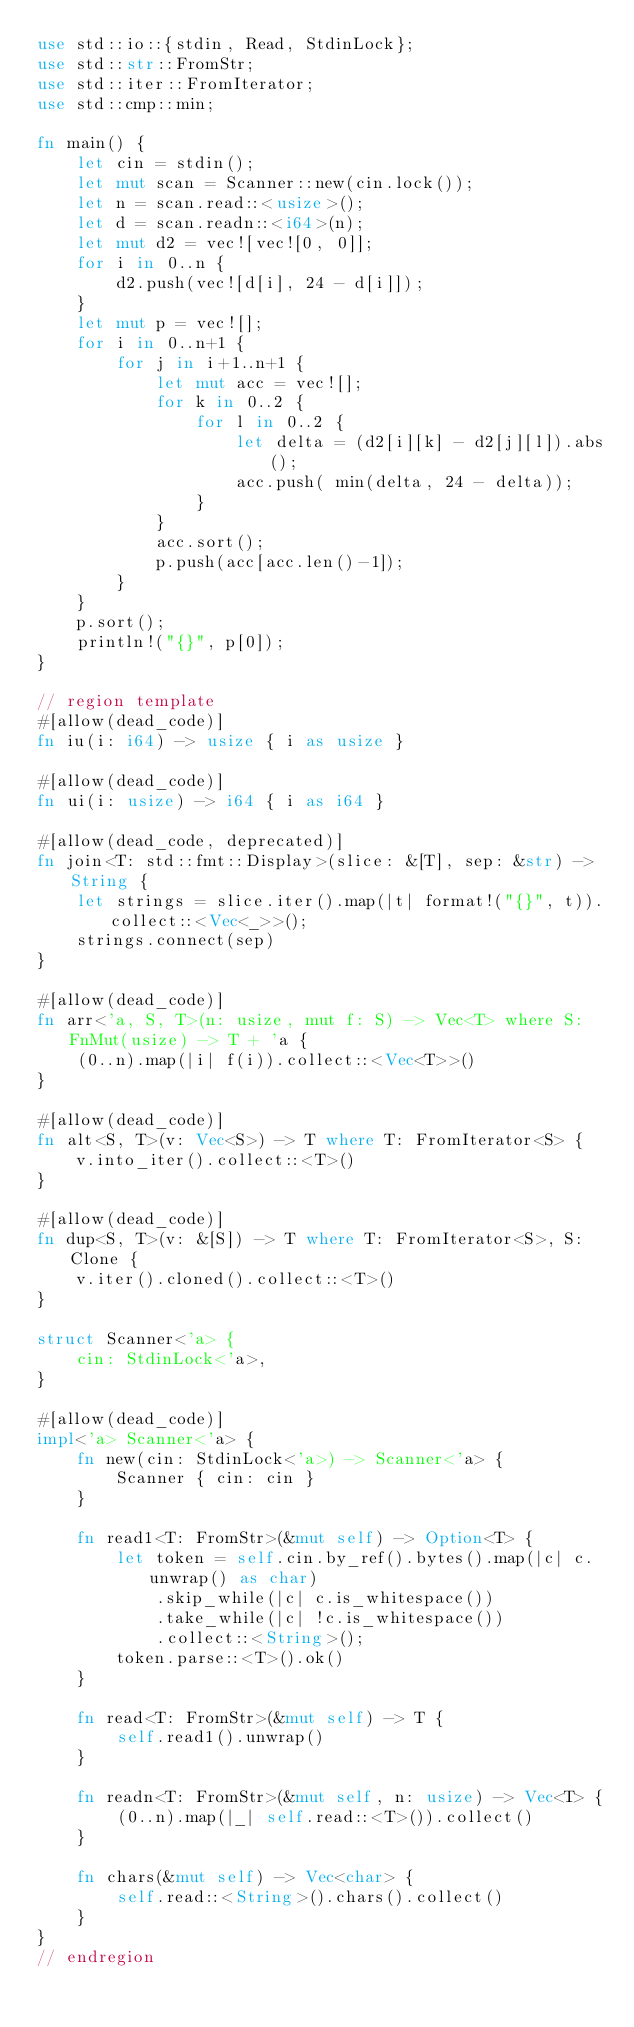Convert code to text. <code><loc_0><loc_0><loc_500><loc_500><_Rust_>use std::io::{stdin, Read, StdinLock};
use std::str::FromStr;
use std::iter::FromIterator;
use std::cmp::min;

fn main() {
    let cin = stdin();
    let mut scan = Scanner::new(cin.lock());
    let n = scan.read::<usize>();
    let d = scan.readn::<i64>(n);
    let mut d2 = vec![vec![0, 0]];
    for i in 0..n {
        d2.push(vec![d[i], 24 - d[i]]);
    }
    let mut p = vec![];
    for i in 0..n+1 {
        for j in i+1..n+1 {
            let mut acc = vec![];
            for k in 0..2 {
                for l in 0..2 {
                    let delta = (d2[i][k] - d2[j][l]).abs();
                    acc.push( min(delta, 24 - delta));
                }
            }
            acc.sort();
            p.push(acc[acc.len()-1]);
        }
    }
    p.sort();
    println!("{}", p[0]);
}

// region template
#[allow(dead_code)]
fn iu(i: i64) -> usize { i as usize }

#[allow(dead_code)]
fn ui(i: usize) -> i64 { i as i64 }

#[allow(dead_code, deprecated)]
fn join<T: std::fmt::Display>(slice: &[T], sep: &str) -> String {
    let strings = slice.iter().map(|t| format!("{}", t)).collect::<Vec<_>>();
    strings.connect(sep)
}

#[allow(dead_code)]
fn arr<'a, S, T>(n: usize, mut f: S) -> Vec<T> where S: FnMut(usize) -> T + 'a {
    (0..n).map(|i| f(i)).collect::<Vec<T>>()
}

#[allow(dead_code)]
fn alt<S, T>(v: Vec<S>) -> T where T: FromIterator<S> {
    v.into_iter().collect::<T>()
}

#[allow(dead_code)]
fn dup<S, T>(v: &[S]) -> T where T: FromIterator<S>, S: Clone {
    v.iter().cloned().collect::<T>()
}

struct Scanner<'a> {
    cin: StdinLock<'a>,
}

#[allow(dead_code)]
impl<'a> Scanner<'a> {
    fn new(cin: StdinLock<'a>) -> Scanner<'a> {
        Scanner { cin: cin }
    }

    fn read1<T: FromStr>(&mut self) -> Option<T> {
        let token = self.cin.by_ref().bytes().map(|c| c.unwrap() as char)
            .skip_while(|c| c.is_whitespace())
            .take_while(|c| !c.is_whitespace())
            .collect::<String>();
        token.parse::<T>().ok()
    }

    fn read<T: FromStr>(&mut self) -> T {
        self.read1().unwrap()
    }

    fn readn<T: FromStr>(&mut self, n: usize) -> Vec<T> {
        (0..n).map(|_| self.read::<T>()).collect()
    }

    fn chars(&mut self) -> Vec<char> {
        self.read::<String>().chars().collect()
    }
}
// endregion</code> 